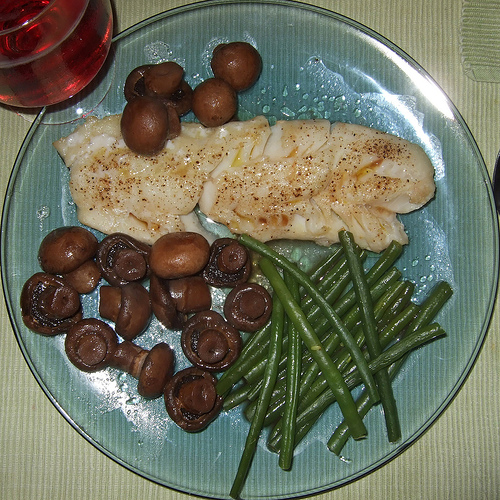<image>
Is the mushroom under the fish? No. The mushroom is not positioned under the fish. The vertical relationship between these objects is different. 